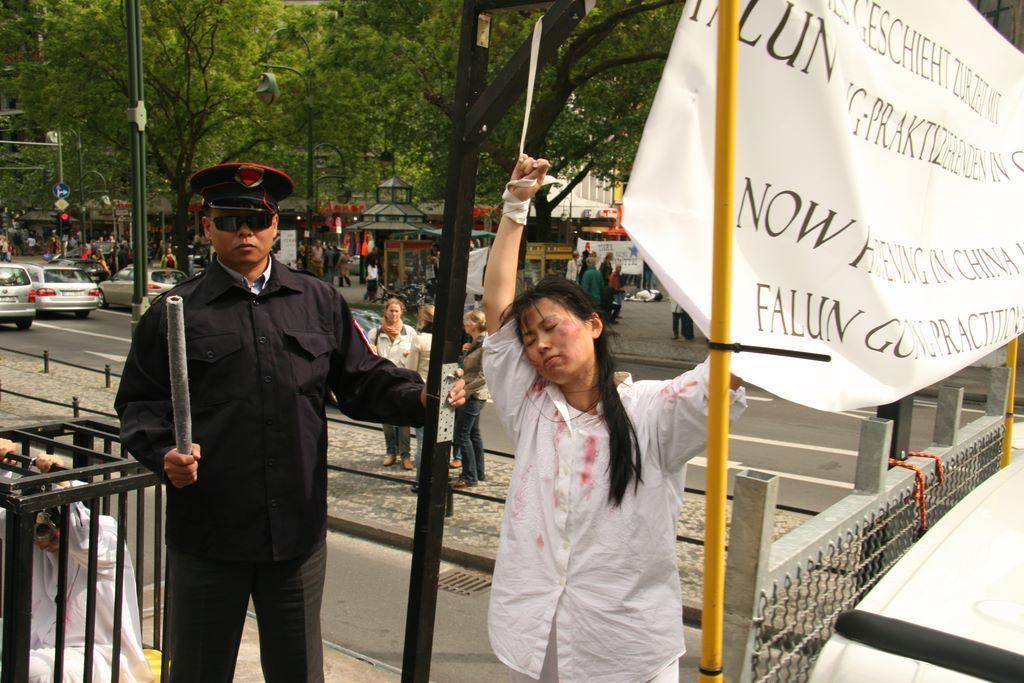Please provide a concise description of this image. In this picture we can see a man, woman, he is holding a stick, wearing a cap, goggles, here we can see banners, fence, people, metal poles, electric poles, people, vehicles, traffic signal, direction board, poster, road, sheds and some objects and in the background we can see trees. 